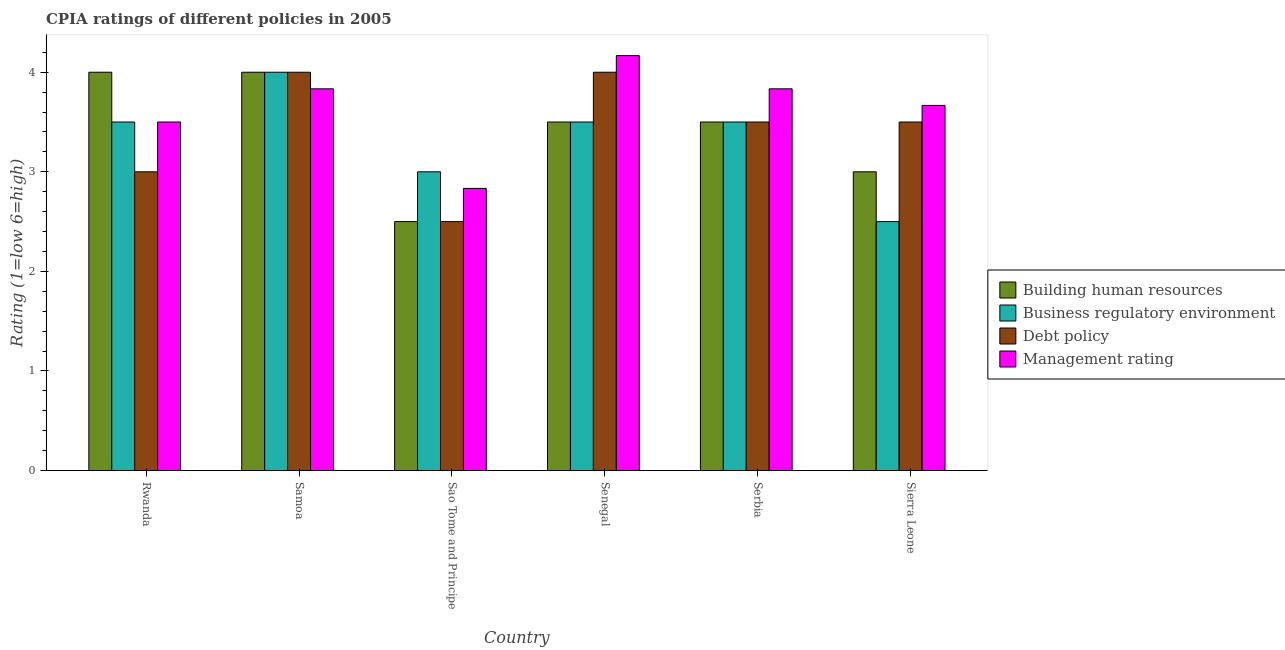How many different coloured bars are there?
Give a very brief answer. 4. Are the number of bars per tick equal to the number of legend labels?
Keep it short and to the point. Yes. Are the number of bars on each tick of the X-axis equal?
Make the answer very short. Yes. How many bars are there on the 4th tick from the right?
Keep it short and to the point. 4. What is the label of the 1st group of bars from the left?
Offer a very short reply. Rwanda. In how many cases, is the number of bars for a given country not equal to the number of legend labels?
Your answer should be very brief. 0. Across all countries, what is the minimum cpia rating of building human resources?
Provide a succinct answer. 2.5. In which country was the cpia rating of building human resources maximum?
Provide a short and direct response. Rwanda. In which country was the cpia rating of management minimum?
Your answer should be very brief. Sao Tome and Principe. What is the total cpia rating of business regulatory environment in the graph?
Give a very brief answer. 20. What is the difference between the cpia rating of management in Sao Tome and Principe and that in Serbia?
Your answer should be compact. -1. What is the difference between the cpia rating of building human resources in Senegal and the cpia rating of management in Sao Tome and Principe?
Keep it short and to the point. 0.67. What is the average cpia rating of building human resources per country?
Make the answer very short. 3.42. What is the difference between the cpia rating of business regulatory environment and cpia rating of debt policy in Senegal?
Ensure brevity in your answer.  -0.5. In how many countries, is the cpia rating of management greater than 1 ?
Your response must be concise. 6. What is the ratio of the cpia rating of building human resources in Rwanda to that in Serbia?
Provide a succinct answer. 1.14. Is the cpia rating of building human resources in Rwanda less than that in Samoa?
Your response must be concise. No. Is the difference between the cpia rating of building human resources in Samoa and Sao Tome and Principe greater than the difference between the cpia rating of business regulatory environment in Samoa and Sao Tome and Principe?
Keep it short and to the point. Yes. What is the difference between the highest and the lowest cpia rating of building human resources?
Offer a terse response. 1.5. Is it the case that in every country, the sum of the cpia rating of debt policy and cpia rating of building human resources is greater than the sum of cpia rating of management and cpia rating of business regulatory environment?
Ensure brevity in your answer.  No. What does the 4th bar from the left in Sao Tome and Principe represents?
Keep it short and to the point. Management rating. What does the 3rd bar from the right in Rwanda represents?
Provide a succinct answer. Business regulatory environment. Does the graph contain grids?
Your answer should be very brief. No. Where does the legend appear in the graph?
Make the answer very short. Center right. How many legend labels are there?
Your response must be concise. 4. How are the legend labels stacked?
Your answer should be compact. Vertical. What is the title of the graph?
Your answer should be compact. CPIA ratings of different policies in 2005. Does "Others" appear as one of the legend labels in the graph?
Your answer should be compact. No. What is the label or title of the X-axis?
Keep it short and to the point. Country. What is the Rating (1=low 6=high) of Building human resources in Rwanda?
Your answer should be compact. 4. What is the Rating (1=low 6=high) in Business regulatory environment in Rwanda?
Your answer should be compact. 3.5. What is the Rating (1=low 6=high) of Building human resources in Samoa?
Offer a terse response. 4. What is the Rating (1=low 6=high) of Business regulatory environment in Samoa?
Ensure brevity in your answer.  4. What is the Rating (1=low 6=high) of Management rating in Samoa?
Ensure brevity in your answer.  3.83. What is the Rating (1=low 6=high) of Management rating in Sao Tome and Principe?
Make the answer very short. 2.83. What is the Rating (1=low 6=high) in Business regulatory environment in Senegal?
Give a very brief answer. 3.5. What is the Rating (1=low 6=high) of Debt policy in Senegal?
Your answer should be very brief. 4. What is the Rating (1=low 6=high) of Management rating in Senegal?
Your answer should be very brief. 4.17. What is the Rating (1=low 6=high) in Debt policy in Serbia?
Your response must be concise. 3.5. What is the Rating (1=low 6=high) in Management rating in Serbia?
Keep it short and to the point. 3.83. What is the Rating (1=low 6=high) of Building human resources in Sierra Leone?
Your answer should be compact. 3. What is the Rating (1=low 6=high) in Business regulatory environment in Sierra Leone?
Offer a very short reply. 2.5. What is the Rating (1=low 6=high) of Debt policy in Sierra Leone?
Provide a succinct answer. 3.5. What is the Rating (1=low 6=high) of Management rating in Sierra Leone?
Offer a very short reply. 3.67. Across all countries, what is the maximum Rating (1=low 6=high) of Building human resources?
Offer a very short reply. 4. Across all countries, what is the maximum Rating (1=low 6=high) of Business regulatory environment?
Give a very brief answer. 4. Across all countries, what is the maximum Rating (1=low 6=high) of Management rating?
Offer a very short reply. 4.17. Across all countries, what is the minimum Rating (1=low 6=high) of Debt policy?
Offer a very short reply. 2.5. Across all countries, what is the minimum Rating (1=low 6=high) in Management rating?
Ensure brevity in your answer.  2.83. What is the total Rating (1=low 6=high) in Building human resources in the graph?
Provide a short and direct response. 20.5. What is the total Rating (1=low 6=high) of Management rating in the graph?
Offer a terse response. 21.83. What is the difference between the Rating (1=low 6=high) of Building human resources in Rwanda and that in Samoa?
Ensure brevity in your answer.  0. What is the difference between the Rating (1=low 6=high) of Debt policy in Rwanda and that in Samoa?
Your answer should be very brief. -1. What is the difference between the Rating (1=low 6=high) in Building human resources in Rwanda and that in Sao Tome and Principe?
Your answer should be very brief. 1.5. What is the difference between the Rating (1=low 6=high) in Debt policy in Rwanda and that in Sao Tome and Principe?
Give a very brief answer. 0.5. What is the difference between the Rating (1=low 6=high) in Management rating in Rwanda and that in Sao Tome and Principe?
Your answer should be compact. 0.67. What is the difference between the Rating (1=low 6=high) of Business regulatory environment in Rwanda and that in Senegal?
Make the answer very short. 0. What is the difference between the Rating (1=low 6=high) of Debt policy in Rwanda and that in Senegal?
Your answer should be very brief. -1. What is the difference between the Rating (1=low 6=high) in Management rating in Rwanda and that in Senegal?
Keep it short and to the point. -0.67. What is the difference between the Rating (1=low 6=high) of Business regulatory environment in Rwanda and that in Serbia?
Make the answer very short. 0. What is the difference between the Rating (1=low 6=high) of Debt policy in Rwanda and that in Serbia?
Keep it short and to the point. -0.5. What is the difference between the Rating (1=low 6=high) in Business regulatory environment in Rwanda and that in Sierra Leone?
Your response must be concise. 1. What is the difference between the Rating (1=low 6=high) in Building human resources in Samoa and that in Sao Tome and Principe?
Offer a terse response. 1.5. What is the difference between the Rating (1=low 6=high) of Business regulatory environment in Samoa and that in Senegal?
Offer a terse response. 0.5. What is the difference between the Rating (1=low 6=high) of Debt policy in Samoa and that in Senegal?
Give a very brief answer. 0. What is the difference between the Rating (1=low 6=high) in Management rating in Samoa and that in Senegal?
Make the answer very short. -0.33. What is the difference between the Rating (1=low 6=high) of Building human resources in Samoa and that in Serbia?
Provide a short and direct response. 0.5. What is the difference between the Rating (1=low 6=high) of Business regulatory environment in Samoa and that in Serbia?
Offer a terse response. 0.5. What is the difference between the Rating (1=low 6=high) in Building human resources in Samoa and that in Sierra Leone?
Keep it short and to the point. 1. What is the difference between the Rating (1=low 6=high) in Management rating in Samoa and that in Sierra Leone?
Your answer should be very brief. 0.17. What is the difference between the Rating (1=low 6=high) in Management rating in Sao Tome and Principe and that in Senegal?
Make the answer very short. -1.33. What is the difference between the Rating (1=low 6=high) of Building human resources in Sao Tome and Principe and that in Serbia?
Make the answer very short. -1. What is the difference between the Rating (1=low 6=high) in Management rating in Sao Tome and Principe and that in Serbia?
Provide a succinct answer. -1. What is the difference between the Rating (1=low 6=high) in Building human resources in Sao Tome and Principe and that in Sierra Leone?
Ensure brevity in your answer.  -0.5. What is the difference between the Rating (1=low 6=high) in Business regulatory environment in Sao Tome and Principe and that in Sierra Leone?
Provide a short and direct response. 0.5. What is the difference between the Rating (1=low 6=high) in Management rating in Sao Tome and Principe and that in Sierra Leone?
Provide a short and direct response. -0.83. What is the difference between the Rating (1=low 6=high) in Building human resources in Senegal and that in Serbia?
Offer a very short reply. 0. What is the difference between the Rating (1=low 6=high) in Management rating in Senegal and that in Serbia?
Your answer should be compact. 0.33. What is the difference between the Rating (1=low 6=high) of Building human resources in Senegal and that in Sierra Leone?
Make the answer very short. 0.5. What is the difference between the Rating (1=low 6=high) in Business regulatory environment in Senegal and that in Sierra Leone?
Make the answer very short. 1. What is the difference between the Rating (1=low 6=high) of Debt policy in Senegal and that in Sierra Leone?
Give a very brief answer. 0.5. What is the difference between the Rating (1=low 6=high) of Building human resources in Serbia and that in Sierra Leone?
Make the answer very short. 0.5. What is the difference between the Rating (1=low 6=high) of Debt policy in Serbia and that in Sierra Leone?
Your answer should be compact. 0. What is the difference between the Rating (1=low 6=high) in Management rating in Serbia and that in Sierra Leone?
Provide a short and direct response. 0.17. What is the difference between the Rating (1=low 6=high) of Building human resources in Rwanda and the Rating (1=low 6=high) of Business regulatory environment in Samoa?
Give a very brief answer. 0. What is the difference between the Rating (1=low 6=high) of Debt policy in Rwanda and the Rating (1=low 6=high) of Management rating in Samoa?
Provide a short and direct response. -0.83. What is the difference between the Rating (1=low 6=high) in Business regulatory environment in Rwanda and the Rating (1=low 6=high) in Management rating in Sao Tome and Principe?
Your answer should be compact. 0.67. What is the difference between the Rating (1=low 6=high) in Building human resources in Rwanda and the Rating (1=low 6=high) in Business regulatory environment in Senegal?
Your response must be concise. 0.5. What is the difference between the Rating (1=low 6=high) in Building human resources in Rwanda and the Rating (1=low 6=high) in Debt policy in Senegal?
Offer a very short reply. 0. What is the difference between the Rating (1=low 6=high) of Business regulatory environment in Rwanda and the Rating (1=low 6=high) of Management rating in Senegal?
Your answer should be compact. -0.67. What is the difference between the Rating (1=low 6=high) of Debt policy in Rwanda and the Rating (1=low 6=high) of Management rating in Senegal?
Your answer should be compact. -1.17. What is the difference between the Rating (1=low 6=high) of Business regulatory environment in Rwanda and the Rating (1=low 6=high) of Debt policy in Serbia?
Make the answer very short. 0. What is the difference between the Rating (1=low 6=high) of Building human resources in Rwanda and the Rating (1=low 6=high) of Debt policy in Sierra Leone?
Keep it short and to the point. 0.5. What is the difference between the Rating (1=low 6=high) in Debt policy in Rwanda and the Rating (1=low 6=high) in Management rating in Sierra Leone?
Offer a terse response. -0.67. What is the difference between the Rating (1=low 6=high) in Building human resources in Samoa and the Rating (1=low 6=high) in Management rating in Sao Tome and Principe?
Provide a short and direct response. 1.17. What is the difference between the Rating (1=low 6=high) in Business regulatory environment in Samoa and the Rating (1=low 6=high) in Management rating in Sao Tome and Principe?
Make the answer very short. 1.17. What is the difference between the Rating (1=low 6=high) in Debt policy in Samoa and the Rating (1=low 6=high) in Management rating in Sao Tome and Principe?
Offer a terse response. 1.17. What is the difference between the Rating (1=low 6=high) of Building human resources in Samoa and the Rating (1=low 6=high) of Debt policy in Senegal?
Ensure brevity in your answer.  0. What is the difference between the Rating (1=low 6=high) of Building human resources in Samoa and the Rating (1=low 6=high) of Business regulatory environment in Serbia?
Keep it short and to the point. 0.5. What is the difference between the Rating (1=low 6=high) in Building human resources in Samoa and the Rating (1=low 6=high) in Debt policy in Serbia?
Offer a very short reply. 0.5. What is the difference between the Rating (1=low 6=high) of Debt policy in Samoa and the Rating (1=low 6=high) of Management rating in Serbia?
Offer a terse response. 0.17. What is the difference between the Rating (1=low 6=high) of Building human resources in Samoa and the Rating (1=low 6=high) of Debt policy in Sierra Leone?
Provide a succinct answer. 0.5. What is the difference between the Rating (1=low 6=high) in Building human resources in Samoa and the Rating (1=low 6=high) in Management rating in Sierra Leone?
Make the answer very short. 0.33. What is the difference between the Rating (1=low 6=high) of Business regulatory environment in Samoa and the Rating (1=low 6=high) of Debt policy in Sierra Leone?
Provide a short and direct response. 0.5. What is the difference between the Rating (1=low 6=high) in Business regulatory environment in Samoa and the Rating (1=low 6=high) in Management rating in Sierra Leone?
Make the answer very short. 0.33. What is the difference between the Rating (1=low 6=high) of Debt policy in Samoa and the Rating (1=low 6=high) of Management rating in Sierra Leone?
Your answer should be very brief. 0.33. What is the difference between the Rating (1=low 6=high) in Building human resources in Sao Tome and Principe and the Rating (1=low 6=high) in Business regulatory environment in Senegal?
Keep it short and to the point. -1. What is the difference between the Rating (1=low 6=high) in Building human resources in Sao Tome and Principe and the Rating (1=low 6=high) in Management rating in Senegal?
Provide a succinct answer. -1.67. What is the difference between the Rating (1=low 6=high) in Business regulatory environment in Sao Tome and Principe and the Rating (1=low 6=high) in Management rating in Senegal?
Offer a terse response. -1.17. What is the difference between the Rating (1=low 6=high) in Debt policy in Sao Tome and Principe and the Rating (1=low 6=high) in Management rating in Senegal?
Provide a short and direct response. -1.67. What is the difference between the Rating (1=low 6=high) of Building human resources in Sao Tome and Principe and the Rating (1=low 6=high) of Business regulatory environment in Serbia?
Ensure brevity in your answer.  -1. What is the difference between the Rating (1=low 6=high) of Building human resources in Sao Tome and Principe and the Rating (1=low 6=high) of Management rating in Serbia?
Provide a short and direct response. -1.33. What is the difference between the Rating (1=low 6=high) in Business regulatory environment in Sao Tome and Principe and the Rating (1=low 6=high) in Management rating in Serbia?
Provide a succinct answer. -0.83. What is the difference between the Rating (1=low 6=high) in Debt policy in Sao Tome and Principe and the Rating (1=low 6=high) in Management rating in Serbia?
Ensure brevity in your answer.  -1.33. What is the difference between the Rating (1=low 6=high) in Building human resources in Sao Tome and Principe and the Rating (1=low 6=high) in Business regulatory environment in Sierra Leone?
Offer a terse response. 0. What is the difference between the Rating (1=low 6=high) of Building human resources in Sao Tome and Principe and the Rating (1=low 6=high) of Debt policy in Sierra Leone?
Make the answer very short. -1. What is the difference between the Rating (1=low 6=high) of Building human resources in Sao Tome and Principe and the Rating (1=low 6=high) of Management rating in Sierra Leone?
Provide a succinct answer. -1.17. What is the difference between the Rating (1=low 6=high) of Business regulatory environment in Sao Tome and Principe and the Rating (1=low 6=high) of Debt policy in Sierra Leone?
Offer a very short reply. -0.5. What is the difference between the Rating (1=low 6=high) in Business regulatory environment in Sao Tome and Principe and the Rating (1=low 6=high) in Management rating in Sierra Leone?
Make the answer very short. -0.67. What is the difference between the Rating (1=low 6=high) in Debt policy in Sao Tome and Principe and the Rating (1=low 6=high) in Management rating in Sierra Leone?
Offer a very short reply. -1.17. What is the difference between the Rating (1=low 6=high) in Building human resources in Senegal and the Rating (1=low 6=high) in Debt policy in Serbia?
Ensure brevity in your answer.  0. What is the difference between the Rating (1=low 6=high) of Business regulatory environment in Senegal and the Rating (1=low 6=high) of Management rating in Serbia?
Your answer should be very brief. -0.33. What is the difference between the Rating (1=low 6=high) in Building human resources in Senegal and the Rating (1=low 6=high) in Business regulatory environment in Sierra Leone?
Provide a short and direct response. 1. What is the difference between the Rating (1=low 6=high) in Building human resources in Senegal and the Rating (1=low 6=high) in Management rating in Sierra Leone?
Your answer should be compact. -0.17. What is the difference between the Rating (1=low 6=high) of Business regulatory environment in Senegal and the Rating (1=low 6=high) of Debt policy in Sierra Leone?
Make the answer very short. 0. What is the difference between the Rating (1=low 6=high) of Building human resources in Serbia and the Rating (1=low 6=high) of Debt policy in Sierra Leone?
Your answer should be very brief. 0. What is the difference between the Rating (1=low 6=high) in Business regulatory environment in Serbia and the Rating (1=low 6=high) in Management rating in Sierra Leone?
Give a very brief answer. -0.17. What is the difference between the Rating (1=low 6=high) in Debt policy in Serbia and the Rating (1=low 6=high) in Management rating in Sierra Leone?
Offer a very short reply. -0.17. What is the average Rating (1=low 6=high) in Building human resources per country?
Your response must be concise. 3.42. What is the average Rating (1=low 6=high) in Business regulatory environment per country?
Your answer should be compact. 3.33. What is the average Rating (1=low 6=high) of Debt policy per country?
Ensure brevity in your answer.  3.42. What is the average Rating (1=low 6=high) in Management rating per country?
Make the answer very short. 3.64. What is the difference between the Rating (1=low 6=high) of Building human resources and Rating (1=low 6=high) of Business regulatory environment in Rwanda?
Provide a succinct answer. 0.5. What is the difference between the Rating (1=low 6=high) of Building human resources and Rating (1=low 6=high) of Debt policy in Rwanda?
Provide a short and direct response. 1. What is the difference between the Rating (1=low 6=high) in Building human resources and Rating (1=low 6=high) in Management rating in Rwanda?
Make the answer very short. 0.5. What is the difference between the Rating (1=low 6=high) of Business regulatory environment and Rating (1=low 6=high) of Debt policy in Rwanda?
Your response must be concise. 0.5. What is the difference between the Rating (1=low 6=high) in Business regulatory environment and Rating (1=low 6=high) in Management rating in Rwanda?
Provide a succinct answer. 0. What is the difference between the Rating (1=low 6=high) of Building human resources and Rating (1=low 6=high) of Debt policy in Samoa?
Give a very brief answer. 0. What is the difference between the Rating (1=low 6=high) in Business regulatory environment and Rating (1=low 6=high) in Debt policy in Samoa?
Your answer should be very brief. 0. What is the difference between the Rating (1=low 6=high) in Business regulatory environment and Rating (1=low 6=high) in Management rating in Sao Tome and Principe?
Your answer should be compact. 0.17. What is the difference between the Rating (1=low 6=high) in Building human resources and Rating (1=low 6=high) in Business regulatory environment in Senegal?
Make the answer very short. 0. What is the difference between the Rating (1=low 6=high) of Building human resources and Rating (1=low 6=high) of Management rating in Senegal?
Offer a terse response. -0.67. What is the difference between the Rating (1=low 6=high) in Business regulatory environment and Rating (1=low 6=high) in Debt policy in Senegal?
Your response must be concise. -0.5. What is the difference between the Rating (1=low 6=high) of Debt policy and Rating (1=low 6=high) of Management rating in Senegal?
Provide a short and direct response. -0.17. What is the difference between the Rating (1=low 6=high) of Building human resources and Rating (1=low 6=high) of Business regulatory environment in Serbia?
Offer a terse response. 0. What is the difference between the Rating (1=low 6=high) in Building human resources and Rating (1=low 6=high) in Debt policy in Serbia?
Give a very brief answer. 0. What is the difference between the Rating (1=low 6=high) in Building human resources and Rating (1=low 6=high) in Management rating in Serbia?
Provide a succinct answer. -0.33. What is the difference between the Rating (1=low 6=high) in Business regulatory environment and Rating (1=low 6=high) in Management rating in Serbia?
Make the answer very short. -0.33. What is the difference between the Rating (1=low 6=high) of Building human resources and Rating (1=low 6=high) of Business regulatory environment in Sierra Leone?
Keep it short and to the point. 0.5. What is the difference between the Rating (1=low 6=high) of Building human resources and Rating (1=low 6=high) of Debt policy in Sierra Leone?
Offer a very short reply. -0.5. What is the difference between the Rating (1=low 6=high) in Building human resources and Rating (1=low 6=high) in Management rating in Sierra Leone?
Offer a terse response. -0.67. What is the difference between the Rating (1=low 6=high) in Business regulatory environment and Rating (1=low 6=high) in Management rating in Sierra Leone?
Your response must be concise. -1.17. What is the ratio of the Rating (1=low 6=high) in Building human resources in Rwanda to that in Sao Tome and Principe?
Keep it short and to the point. 1.6. What is the ratio of the Rating (1=low 6=high) of Business regulatory environment in Rwanda to that in Sao Tome and Principe?
Give a very brief answer. 1.17. What is the ratio of the Rating (1=low 6=high) of Debt policy in Rwanda to that in Sao Tome and Principe?
Offer a very short reply. 1.2. What is the ratio of the Rating (1=low 6=high) of Management rating in Rwanda to that in Sao Tome and Principe?
Give a very brief answer. 1.24. What is the ratio of the Rating (1=low 6=high) in Management rating in Rwanda to that in Senegal?
Offer a very short reply. 0.84. What is the ratio of the Rating (1=low 6=high) in Debt policy in Rwanda to that in Serbia?
Give a very brief answer. 0.86. What is the ratio of the Rating (1=low 6=high) of Building human resources in Rwanda to that in Sierra Leone?
Offer a terse response. 1.33. What is the ratio of the Rating (1=low 6=high) of Management rating in Rwanda to that in Sierra Leone?
Offer a very short reply. 0.95. What is the ratio of the Rating (1=low 6=high) of Building human resources in Samoa to that in Sao Tome and Principe?
Your answer should be compact. 1.6. What is the ratio of the Rating (1=low 6=high) of Business regulatory environment in Samoa to that in Sao Tome and Principe?
Give a very brief answer. 1.33. What is the ratio of the Rating (1=low 6=high) of Management rating in Samoa to that in Sao Tome and Principe?
Offer a terse response. 1.35. What is the ratio of the Rating (1=low 6=high) of Debt policy in Samoa to that in Senegal?
Offer a terse response. 1. What is the ratio of the Rating (1=low 6=high) of Management rating in Samoa to that in Senegal?
Offer a terse response. 0.92. What is the ratio of the Rating (1=low 6=high) of Building human resources in Samoa to that in Serbia?
Provide a short and direct response. 1.14. What is the ratio of the Rating (1=low 6=high) of Debt policy in Samoa to that in Serbia?
Make the answer very short. 1.14. What is the ratio of the Rating (1=low 6=high) of Building human resources in Samoa to that in Sierra Leone?
Give a very brief answer. 1.33. What is the ratio of the Rating (1=low 6=high) in Debt policy in Samoa to that in Sierra Leone?
Offer a terse response. 1.14. What is the ratio of the Rating (1=low 6=high) of Management rating in Samoa to that in Sierra Leone?
Provide a succinct answer. 1.05. What is the ratio of the Rating (1=low 6=high) in Building human resources in Sao Tome and Principe to that in Senegal?
Your answer should be very brief. 0.71. What is the ratio of the Rating (1=low 6=high) of Business regulatory environment in Sao Tome and Principe to that in Senegal?
Keep it short and to the point. 0.86. What is the ratio of the Rating (1=low 6=high) in Management rating in Sao Tome and Principe to that in Senegal?
Offer a very short reply. 0.68. What is the ratio of the Rating (1=low 6=high) in Business regulatory environment in Sao Tome and Principe to that in Serbia?
Provide a short and direct response. 0.86. What is the ratio of the Rating (1=low 6=high) of Debt policy in Sao Tome and Principe to that in Serbia?
Ensure brevity in your answer.  0.71. What is the ratio of the Rating (1=low 6=high) of Management rating in Sao Tome and Principe to that in Serbia?
Give a very brief answer. 0.74. What is the ratio of the Rating (1=low 6=high) in Building human resources in Sao Tome and Principe to that in Sierra Leone?
Keep it short and to the point. 0.83. What is the ratio of the Rating (1=low 6=high) in Business regulatory environment in Sao Tome and Principe to that in Sierra Leone?
Ensure brevity in your answer.  1.2. What is the ratio of the Rating (1=low 6=high) in Debt policy in Sao Tome and Principe to that in Sierra Leone?
Give a very brief answer. 0.71. What is the ratio of the Rating (1=low 6=high) of Management rating in Sao Tome and Principe to that in Sierra Leone?
Offer a terse response. 0.77. What is the ratio of the Rating (1=low 6=high) in Building human resources in Senegal to that in Serbia?
Give a very brief answer. 1. What is the ratio of the Rating (1=low 6=high) of Business regulatory environment in Senegal to that in Serbia?
Offer a terse response. 1. What is the ratio of the Rating (1=low 6=high) in Management rating in Senegal to that in Serbia?
Provide a succinct answer. 1.09. What is the ratio of the Rating (1=low 6=high) in Business regulatory environment in Senegal to that in Sierra Leone?
Offer a terse response. 1.4. What is the ratio of the Rating (1=low 6=high) of Debt policy in Senegal to that in Sierra Leone?
Offer a terse response. 1.14. What is the ratio of the Rating (1=low 6=high) in Management rating in Senegal to that in Sierra Leone?
Make the answer very short. 1.14. What is the ratio of the Rating (1=low 6=high) of Building human resources in Serbia to that in Sierra Leone?
Offer a terse response. 1.17. What is the ratio of the Rating (1=low 6=high) in Management rating in Serbia to that in Sierra Leone?
Provide a short and direct response. 1.05. What is the difference between the highest and the second highest Rating (1=low 6=high) of Building human resources?
Give a very brief answer. 0. What is the difference between the highest and the second highest Rating (1=low 6=high) in Business regulatory environment?
Give a very brief answer. 0.5. What is the difference between the highest and the second highest Rating (1=low 6=high) of Management rating?
Offer a very short reply. 0.33. What is the difference between the highest and the lowest Rating (1=low 6=high) in Debt policy?
Provide a short and direct response. 1.5. 